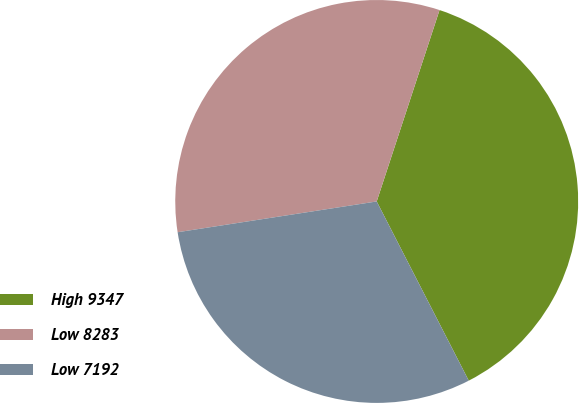Convert chart. <chart><loc_0><loc_0><loc_500><loc_500><pie_chart><fcel>High 9347<fcel>Low 8283<fcel>Low 7192<nl><fcel>37.4%<fcel>32.49%<fcel>30.11%<nl></chart> 